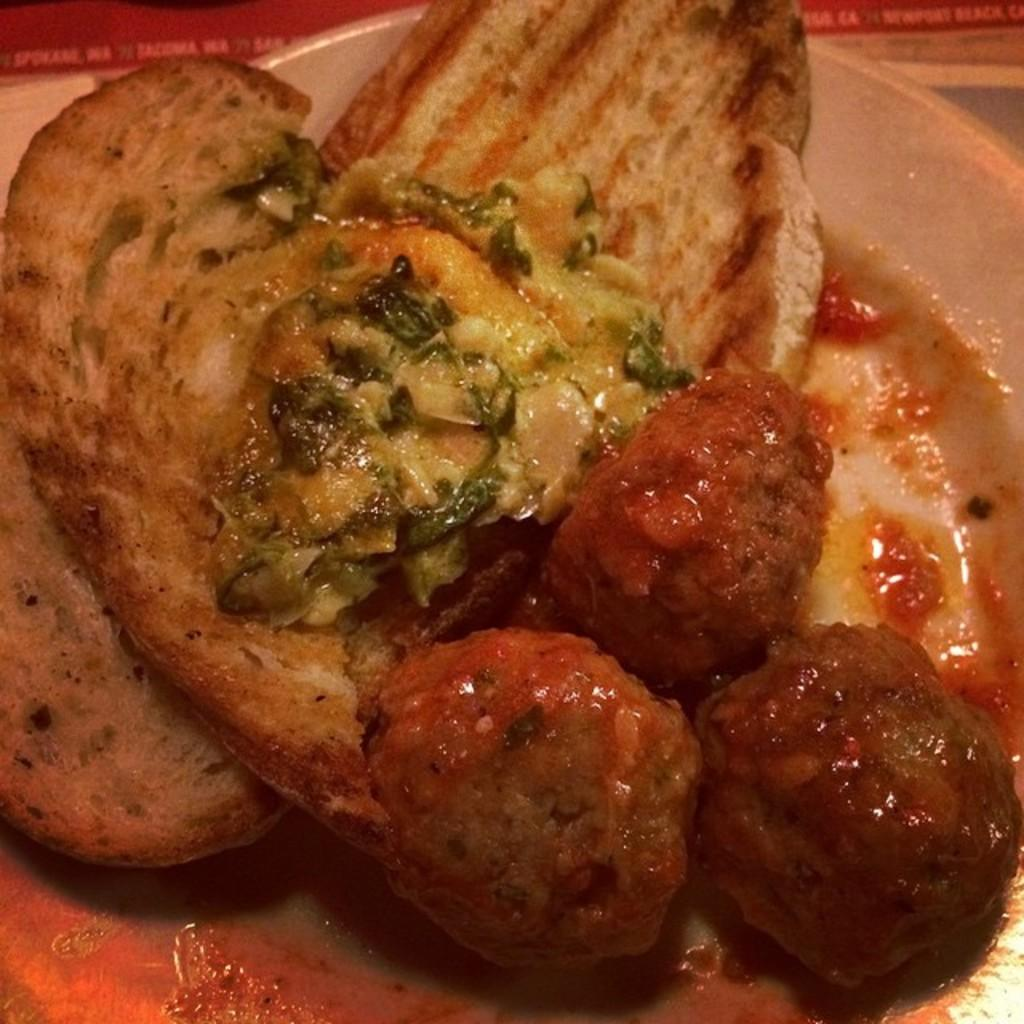What object is present in the image that is typically used for serving food? There is a plate in the image. What is on the plate that is visible in the image? There is food on the plate. What type of pipe can be seen in the image? There is no pipe present in the image. What type of glass object is visible in the image? There is no glass object present in the image. What type of tree can be seen in the image? There is no tree present in the image. 